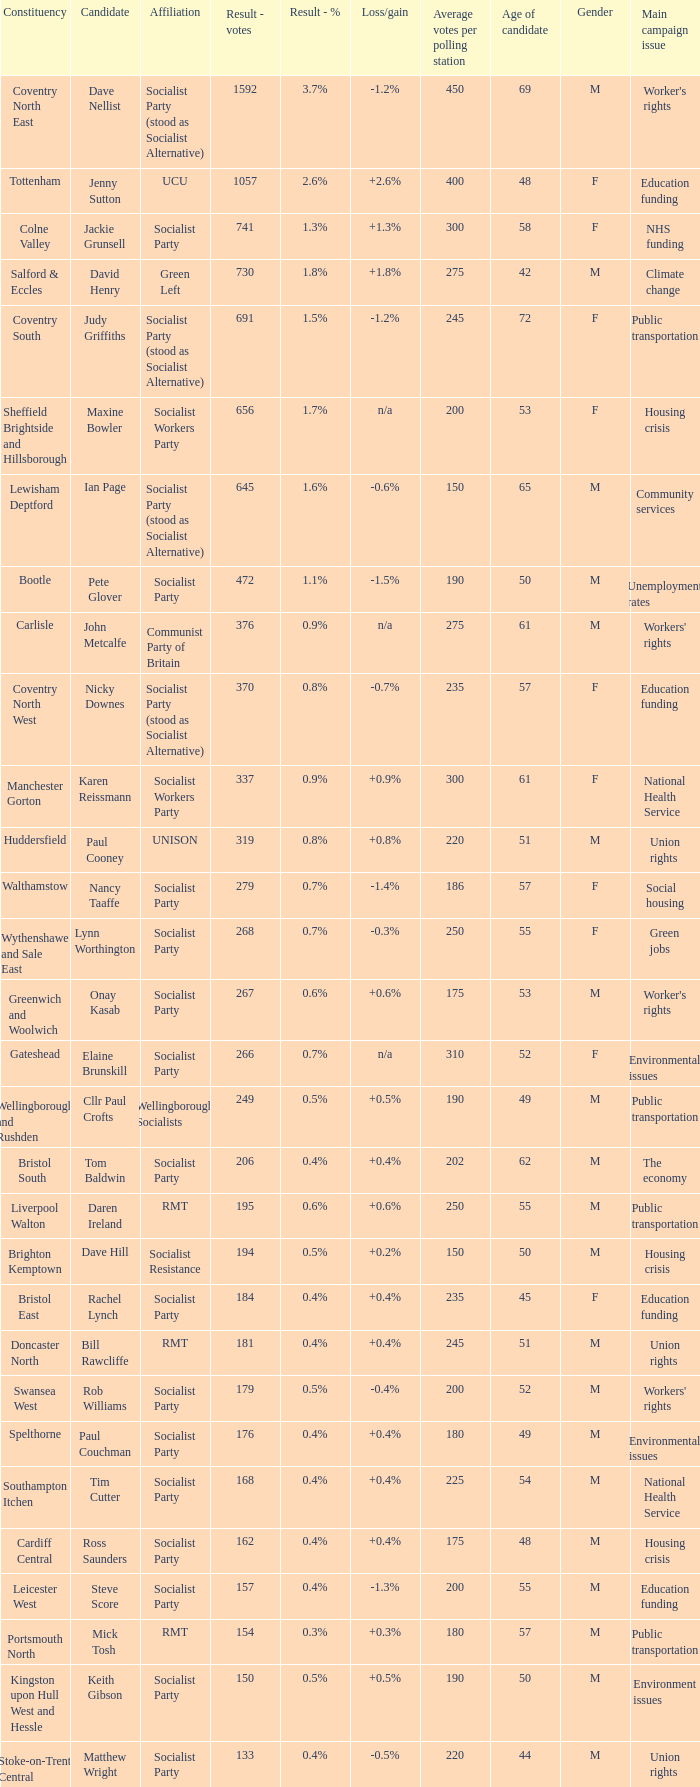I'm looking to parse the entire table for insights. Could you assist me with that? {'header': ['Constituency', 'Candidate', 'Affiliation', 'Result - votes', 'Result - %', 'Loss/gain', 'Average votes per polling station', 'Age of candidate', 'Gender', 'Main campaign issue'], 'rows': [['Coventry North East', 'Dave Nellist', 'Socialist Party (stood as Socialist Alternative)', '1592', '3.7%', '-1.2%', '450', '69', 'M', "Worker's rights"], ['Tottenham', 'Jenny Sutton', 'UCU', '1057', '2.6%', '+2.6%', '400', '48', 'F', 'Education funding'], ['Colne Valley', 'Jackie Grunsell', 'Socialist Party', '741', '1.3%', '+1.3%', '300', '58', 'F', 'NHS funding'], ['Salford & Eccles', 'David Henry', 'Green Left', '730', '1.8%', '+1.8%', '275', '42', 'M', 'Climate change'], ['Coventry South', 'Judy Griffiths', 'Socialist Party (stood as Socialist Alternative)', '691', '1.5%', '-1.2%', '245', '72', 'F', 'Public transportation'], ['Sheffield Brightside and Hillsborough', 'Maxine Bowler', 'Socialist Workers Party', '656', '1.7%', 'n/a', '200', '53', 'F', 'Housing crisis'], ['Lewisham Deptford', 'Ian Page', 'Socialist Party (stood as Socialist Alternative)', '645', '1.6%', '-0.6%', '150', '65', 'M', 'Community services'], ['Bootle', 'Pete Glover', 'Socialist Party', '472', '1.1%', '-1.5%', '190', '50', 'M', 'Unemployment rates'], ['Carlisle', 'John Metcalfe', 'Communist Party of Britain', '376', '0.9%', 'n/a', '275', '61', 'M', "Workers' rights"], ['Coventry North West', 'Nicky Downes', 'Socialist Party (stood as Socialist Alternative)', '370', '0.8%', '-0.7%', '235', '57', 'F', 'Education funding'], ['Manchester Gorton', 'Karen Reissmann', 'Socialist Workers Party', '337', '0.9%', '+0.9%', '300', '61', 'F', 'National Health Service'], ['Huddersfield', 'Paul Cooney', 'UNISON', '319', '0.8%', '+0.8%', '220', '51', 'M', 'Union rights'], ['Walthamstow', 'Nancy Taaffe', 'Socialist Party', '279', '0.7%', '-1.4%', '186', '57', 'F', 'Social housing'], ['Wythenshawe and Sale East', 'Lynn Worthington', 'Socialist Party', '268', '0.7%', '-0.3%', '250', '55', 'F', 'Green jobs'], ['Greenwich and Woolwich', 'Onay Kasab', 'Socialist Party', '267', '0.6%', '+0.6%', '175', '53', 'M', "Worker's rights"], ['Gateshead', 'Elaine Brunskill', 'Socialist Party', '266', '0.7%', 'n/a', '310', '52', 'F', 'Environmental issues'], ['Wellingborough and Rushden', 'Cllr Paul Crofts', 'Wellingborough Socialists', '249', '0.5%', '+0.5%', '190', '49', 'M', 'Public transportation'], ['Bristol South', 'Tom Baldwin', 'Socialist Party', '206', '0.4%', '+0.4%', '202', '62', 'M', 'The economy'], ['Liverpool Walton', 'Daren Ireland', 'RMT', '195', '0.6%', '+0.6%', '250', '55', 'M', 'Public transportation'], ['Brighton Kemptown', 'Dave Hill', 'Socialist Resistance', '194', '0.5%', '+0.2%', '150', '50', 'M', 'Housing crisis'], ['Bristol East', 'Rachel Lynch', 'Socialist Party', '184', '0.4%', '+0.4%', '235', '45', 'F', 'Education funding'], ['Doncaster North', 'Bill Rawcliffe', 'RMT', '181', '0.4%', '+0.4%', '245', '51', 'M', 'Union rights'], ['Swansea West', 'Rob Williams', 'Socialist Party', '179', '0.5%', '-0.4%', '200', '52', 'M', "Workers' rights"], ['Spelthorne', 'Paul Couchman', 'Socialist Party', '176', '0.4%', '+0.4%', '180', '49', 'M', 'Environmental issues'], ['Southampton Itchen', 'Tim Cutter', 'Socialist Party', '168', '0.4%', '+0.4%', '225', '54', 'M', 'National Health Service'], ['Cardiff Central', 'Ross Saunders', 'Socialist Party', '162', '0.4%', '+0.4%', '175', '48', 'M', 'Housing crisis'], ['Leicester West', 'Steve Score', 'Socialist Party', '157', '0.4%', '-1.3%', '200', '55', 'M', 'Education funding'], ['Portsmouth North', 'Mick Tosh', 'RMT', '154', '0.3%', '+0.3%', '180', '57', 'M', 'Public transportation'], ['Kingston upon Hull West and Hessle', 'Keith Gibson', 'Socialist Party', '150', '0.5%', '+0.5%', '190', '50', 'M', 'Environment issues'], ['Stoke-on-Trent Central', 'Matthew Wright', 'Socialist Party', '133', '0.4%', '-0.5%', '220', '44', 'M', 'Union rights']]} What is every candidate for the Cardiff Central constituency? Ross Saunders. 